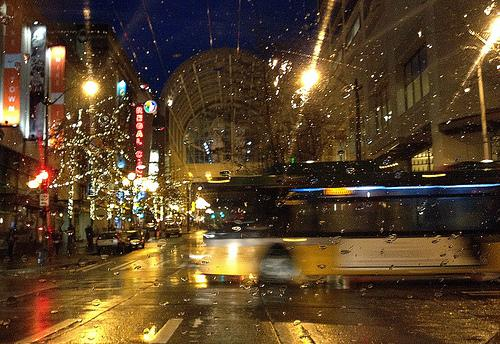Question: what is the vehicle in the center of the screen?
Choices:
A. A train.
B. A trolley.
C. A car.
D. A bus.
Answer with the letter. Answer: D Question: what is on the camera lens?
Choices:
A. Dust.
B. Smudge.
C. Fingerprint.
D. Rain drops.
Answer with the letter. Answer: D Question: what time of the day is it?
Choices:
A. At night.
B. Noon.
C. Morning.
D. After school.
Answer with the letter. Answer: A Question: what is behind the bus?
Choices:
A. Cars.
B. Exhaust fumes.
C. Buildings.
D. A trailer hitch.
Answer with the letter. Answer: C Question: how many buses do you see in the picture?
Choices:
A. Two.
B. Three.
C. Four.
D. One.
Answer with the letter. Answer: D 